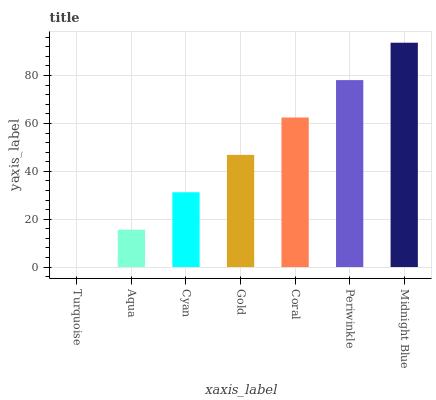Is Turquoise the minimum?
Answer yes or no. Yes. Is Midnight Blue the maximum?
Answer yes or no. Yes. Is Aqua the minimum?
Answer yes or no. No. Is Aqua the maximum?
Answer yes or no. No. Is Aqua greater than Turquoise?
Answer yes or no. Yes. Is Turquoise less than Aqua?
Answer yes or no. Yes. Is Turquoise greater than Aqua?
Answer yes or no. No. Is Aqua less than Turquoise?
Answer yes or no. No. Is Gold the high median?
Answer yes or no. Yes. Is Gold the low median?
Answer yes or no. Yes. Is Coral the high median?
Answer yes or no. No. Is Coral the low median?
Answer yes or no. No. 